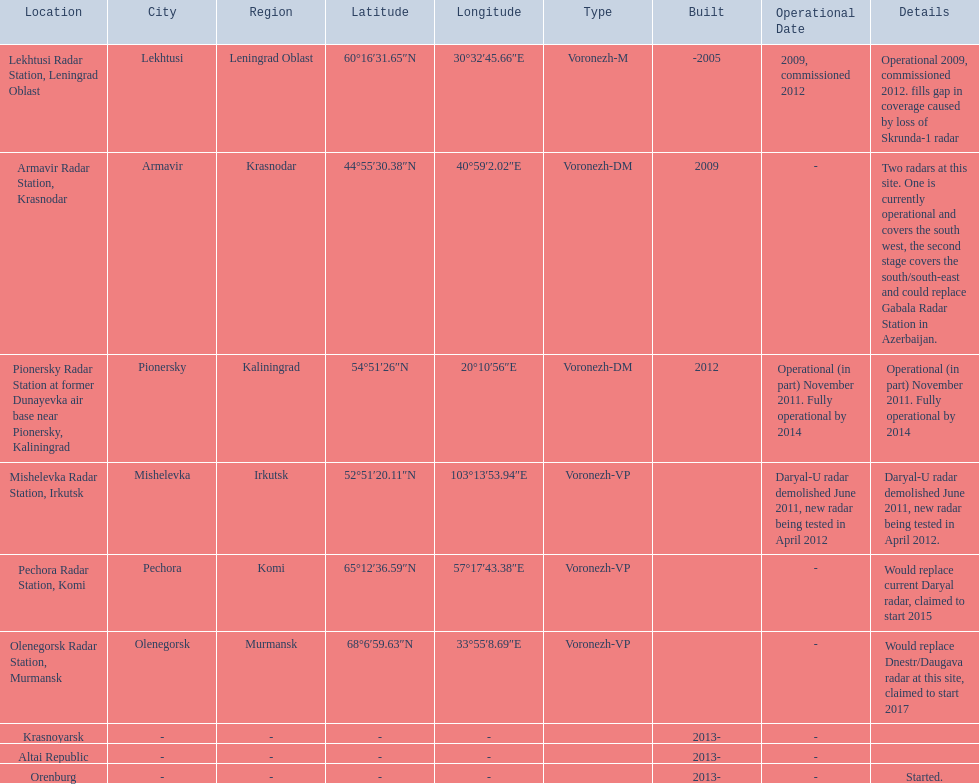What year built is at the top? -2005. 